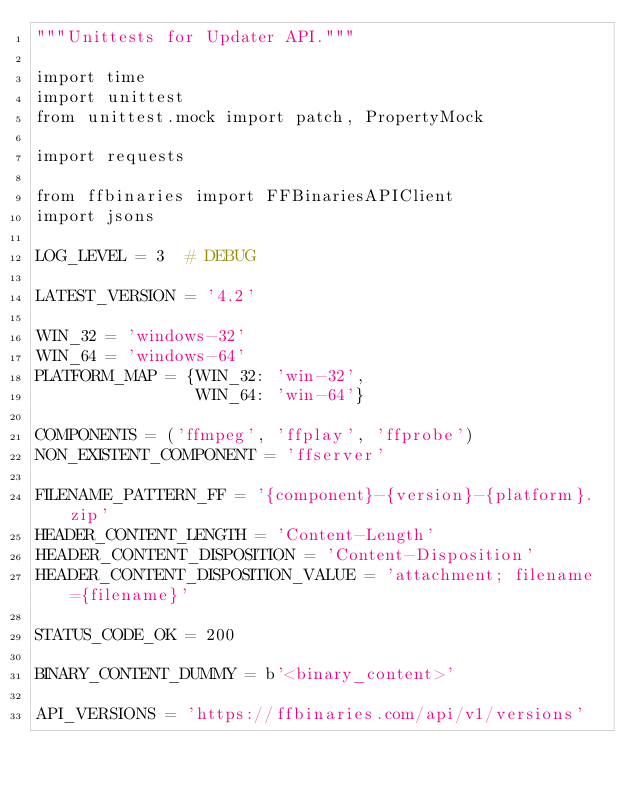<code> <loc_0><loc_0><loc_500><loc_500><_Python_>"""Unittests for Updater API."""

import time
import unittest
from unittest.mock import patch, PropertyMock

import requests

from ffbinaries import FFBinariesAPIClient
import jsons

LOG_LEVEL = 3  # DEBUG

LATEST_VERSION = '4.2'

WIN_32 = 'windows-32'
WIN_64 = 'windows-64'
PLATFORM_MAP = {WIN_32: 'win-32',
                WIN_64: 'win-64'}

COMPONENTS = ('ffmpeg', 'ffplay', 'ffprobe')
NON_EXISTENT_COMPONENT = 'ffserver'

FILENAME_PATTERN_FF = '{component}-{version}-{platform}.zip'
HEADER_CONTENT_LENGTH = 'Content-Length'
HEADER_CONTENT_DISPOSITION = 'Content-Disposition'
HEADER_CONTENT_DISPOSITION_VALUE = 'attachment; filename={filename}'

STATUS_CODE_OK = 200

BINARY_CONTENT_DUMMY = b'<binary_content>'

API_VERSIONS = 'https://ffbinaries.com/api/v1/versions'</code> 